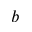Convert formula to latex. <formula><loc_0><loc_0><loc_500><loc_500>b</formula> 